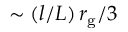Convert formula to latex. <formula><loc_0><loc_0><loc_500><loc_500>\sim ( l / L ) \, r _ { g } / 3</formula> 